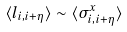Convert formula to latex. <formula><loc_0><loc_0><loc_500><loc_500>\langle l _ { i , i + \eta } \rangle \sim \langle \sigma ^ { x } _ { i , i + \eta } \rangle</formula> 